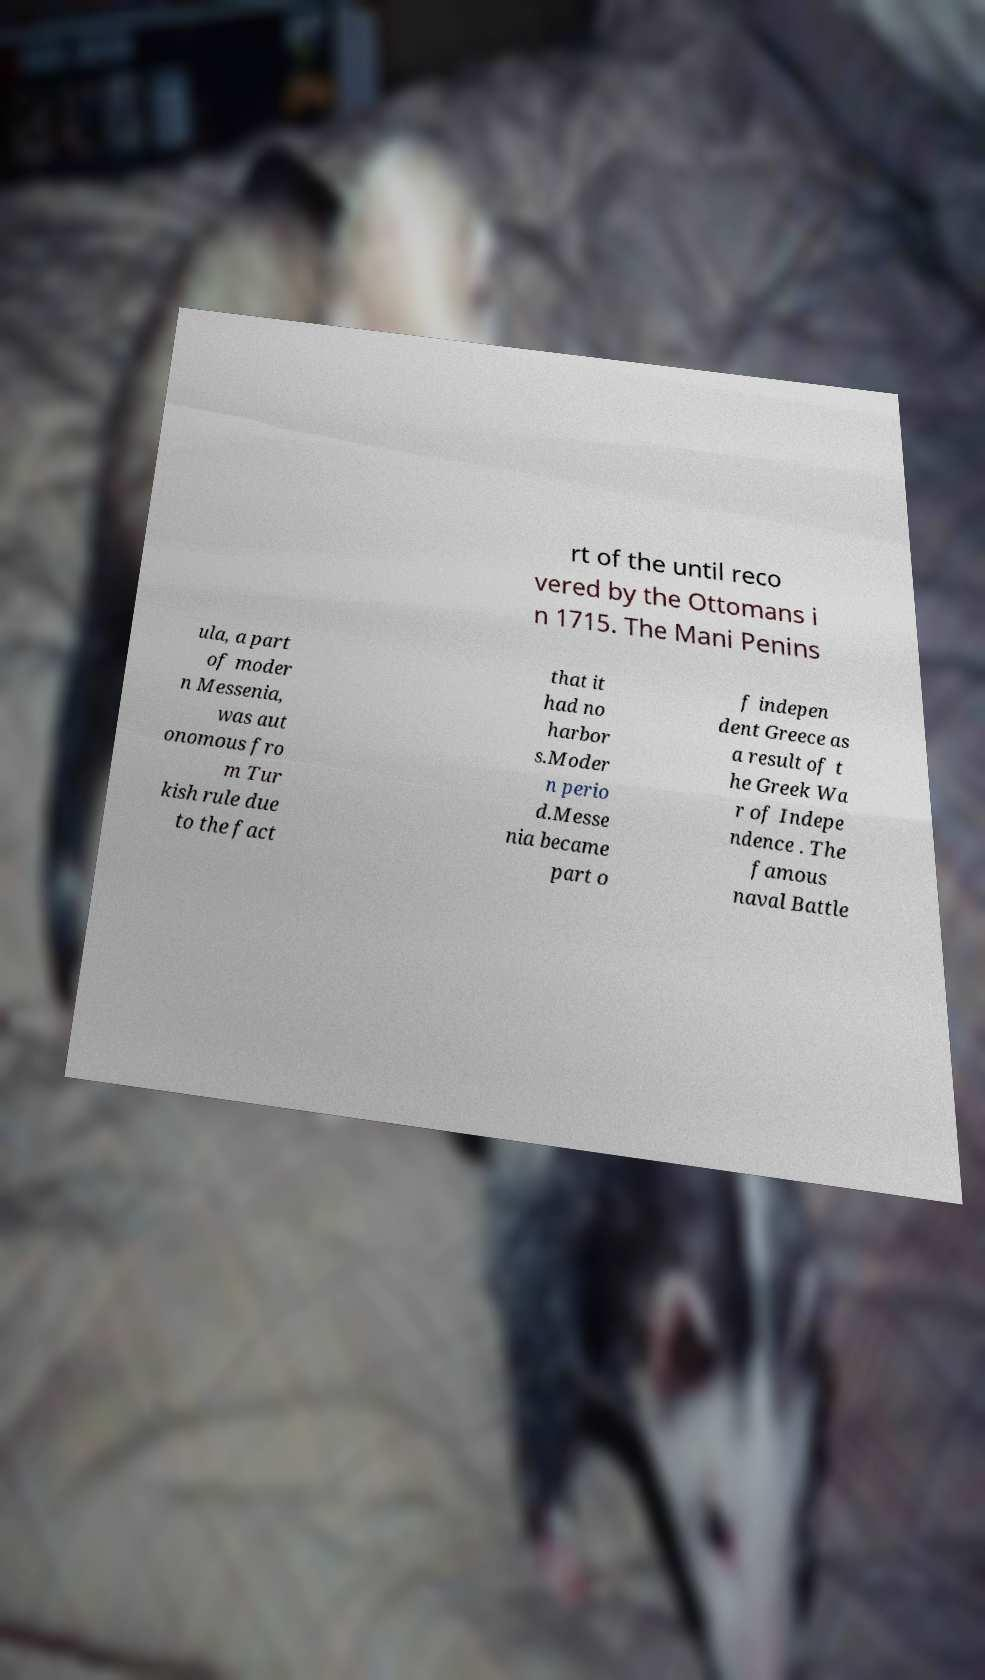There's text embedded in this image that I need extracted. Can you transcribe it verbatim? rt of the until reco vered by the Ottomans i n 1715. The Mani Penins ula, a part of moder n Messenia, was aut onomous fro m Tur kish rule due to the fact that it had no harbor s.Moder n perio d.Messe nia became part o f indepen dent Greece as a result of t he Greek Wa r of Indepe ndence . The famous naval Battle 